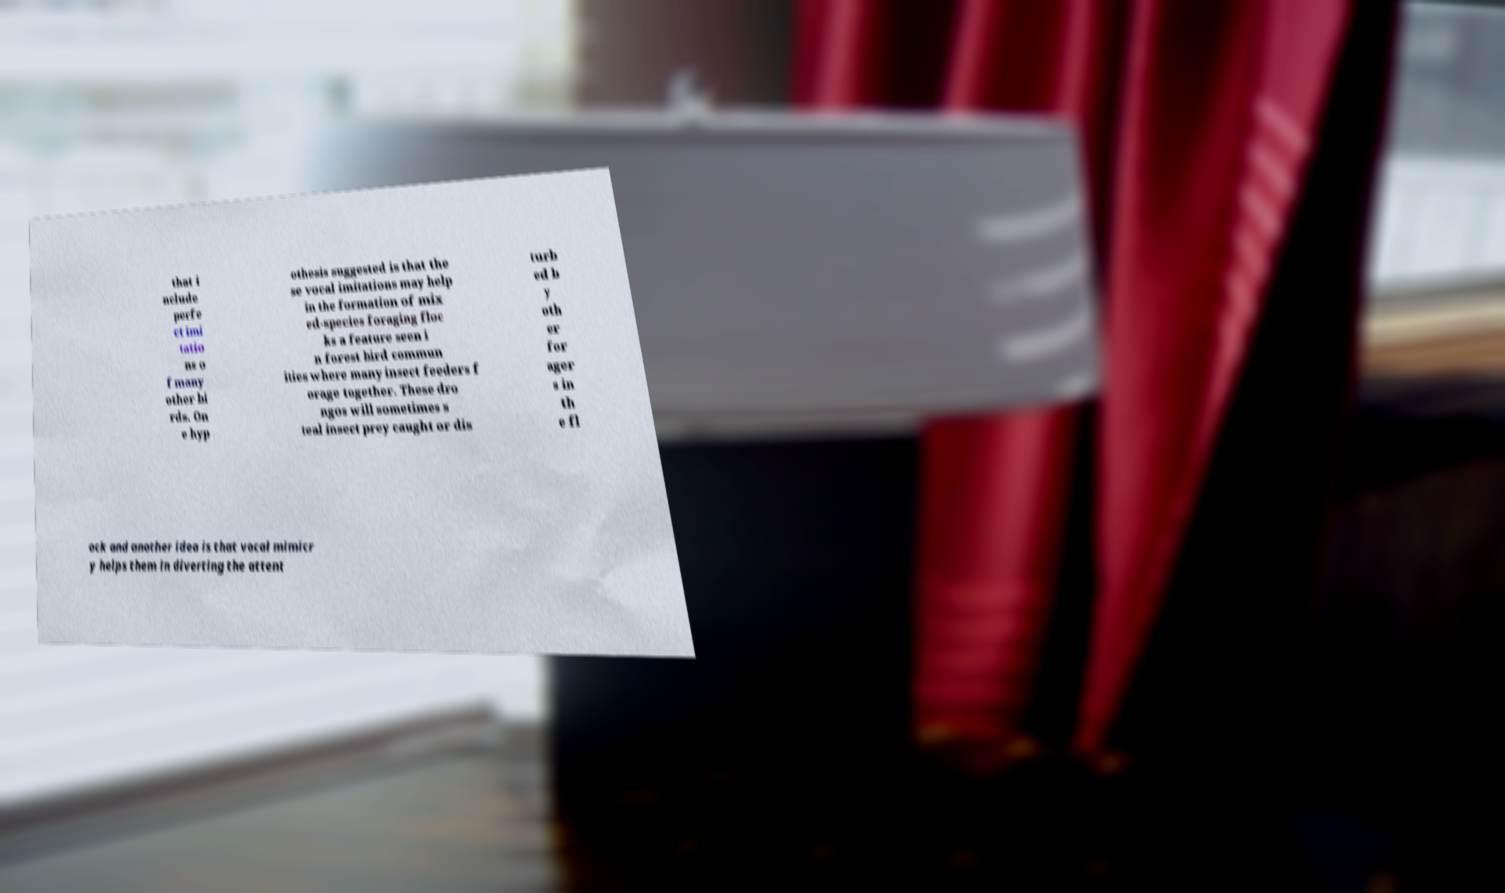Could you assist in decoding the text presented in this image and type it out clearly? that i nclude perfe ct imi tatio ns o f many other bi rds. On e hyp othesis suggested is that the se vocal imitations may help in the formation of mix ed-species foraging floc ks a feature seen i n forest bird commun ities where many insect feeders f orage together. These dro ngos will sometimes s teal insect prey caught or dis turb ed b y oth er for ager s in th e fl ock and another idea is that vocal mimicr y helps them in diverting the attent 